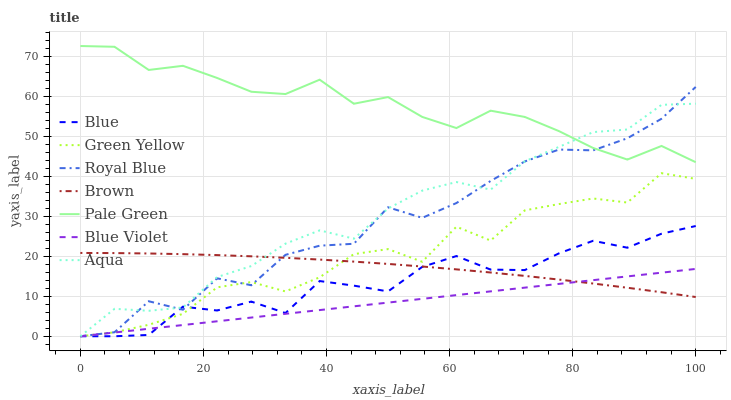Does Blue Violet have the minimum area under the curve?
Answer yes or no. Yes. Does Pale Green have the maximum area under the curve?
Answer yes or no. Yes. Does Brown have the minimum area under the curve?
Answer yes or no. No. Does Brown have the maximum area under the curve?
Answer yes or no. No. Is Blue Violet the smoothest?
Answer yes or no. Yes. Is Royal Blue the roughest?
Answer yes or no. Yes. Is Brown the smoothest?
Answer yes or no. No. Is Brown the roughest?
Answer yes or no. No. Does Blue have the lowest value?
Answer yes or no. Yes. Does Brown have the lowest value?
Answer yes or no. No. Does Pale Green have the highest value?
Answer yes or no. Yes. Does Brown have the highest value?
Answer yes or no. No. Is Blue less than Pale Green?
Answer yes or no. Yes. Is Pale Green greater than Green Yellow?
Answer yes or no. Yes. Does Pale Green intersect Aqua?
Answer yes or no. Yes. Is Pale Green less than Aqua?
Answer yes or no. No. Is Pale Green greater than Aqua?
Answer yes or no. No. Does Blue intersect Pale Green?
Answer yes or no. No. 